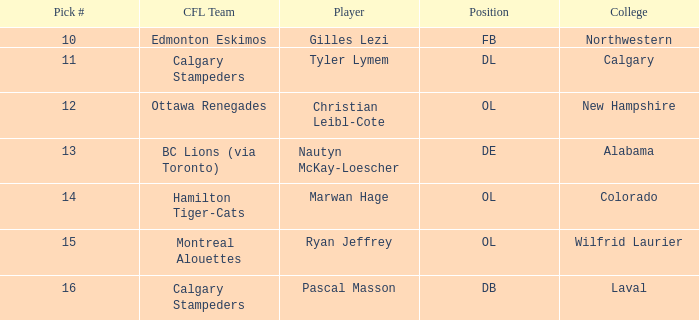What position does Christian Leibl-Cote play? OL. 